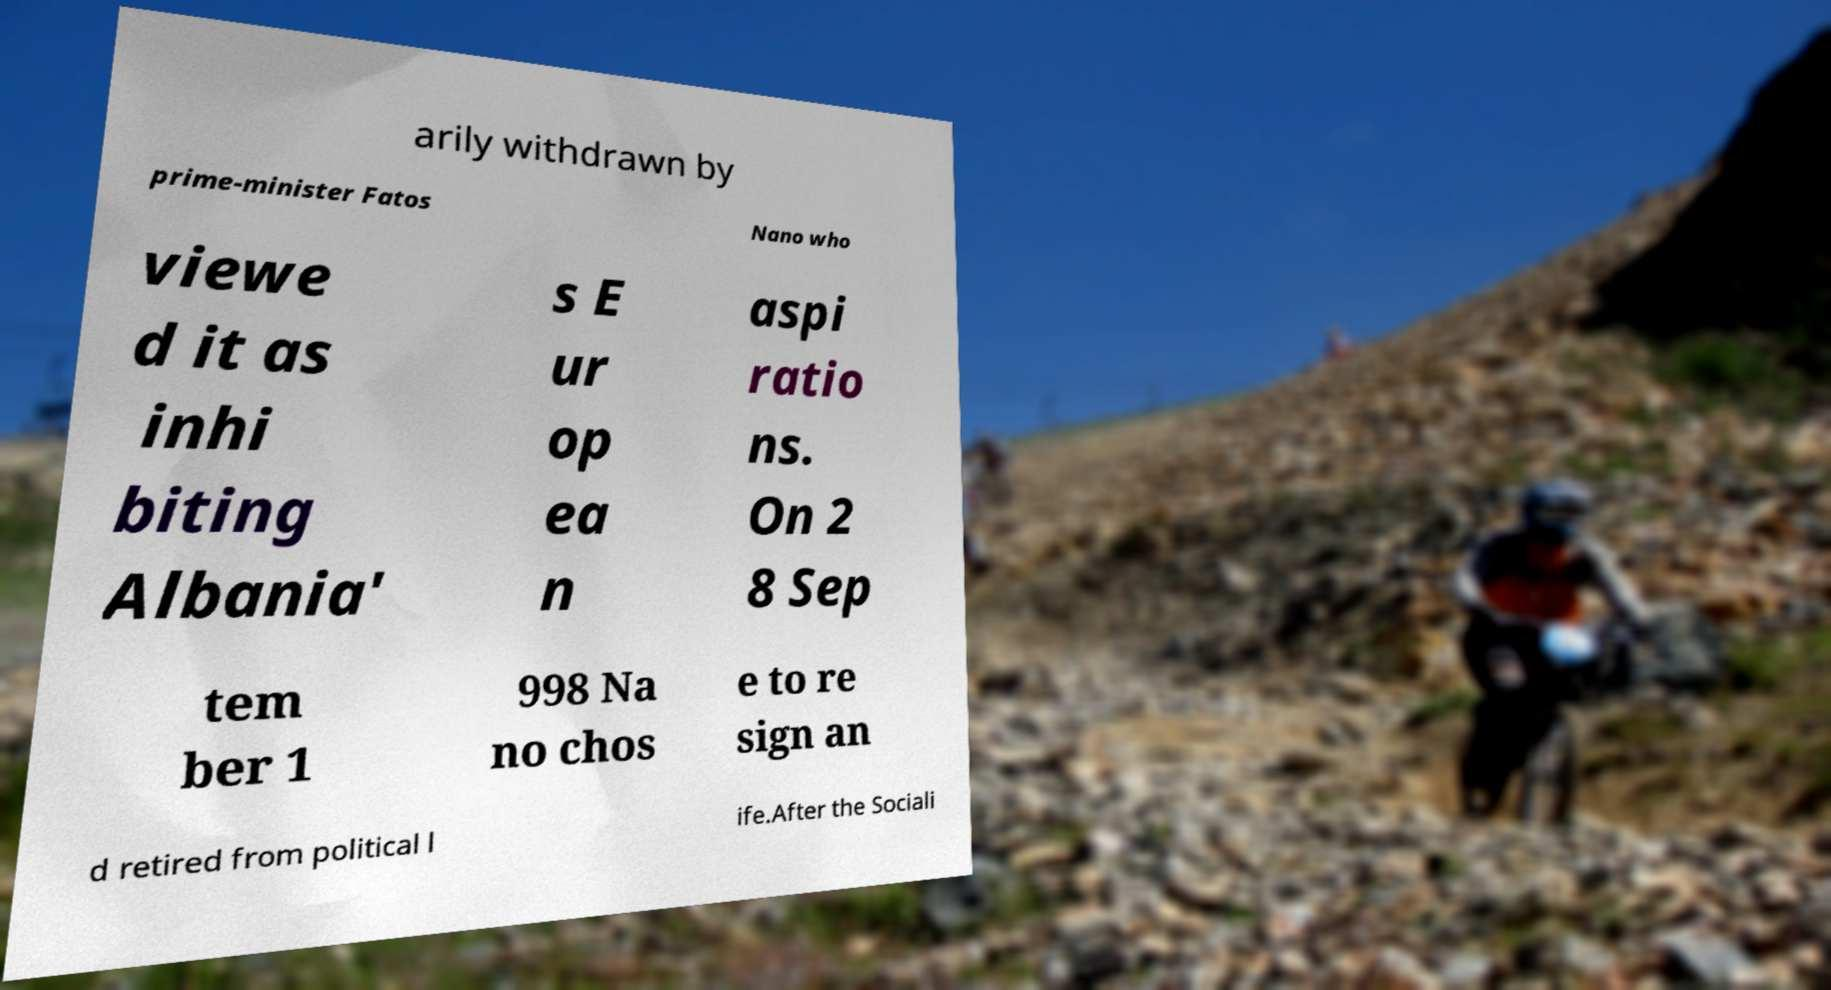Please read and relay the text visible in this image. What does it say? arily withdrawn by prime-minister Fatos Nano who viewe d it as inhi biting Albania' s E ur op ea n aspi ratio ns. On 2 8 Sep tem ber 1 998 Na no chos e to re sign an d retired from political l ife.After the Sociali 